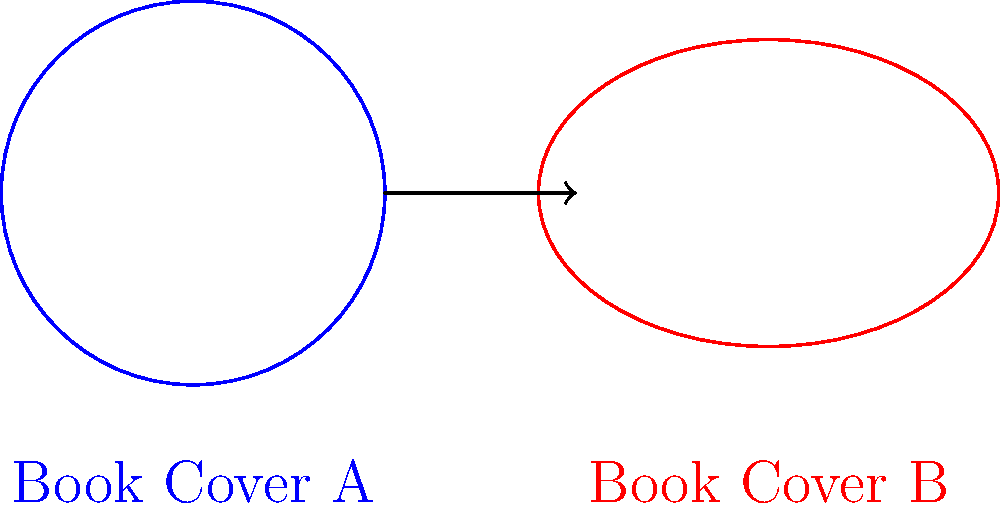Consider two book covers represented by the surfaces shown above: Cover A (blue circle) and Cover B (red ellipse). Are these two surfaces homeomorphic? If so, describe a homeomorphism between them. To determine if the two surfaces are homeomorphic, we need to consider the following steps:

1. Definition of homeomorphism: Two topological spaces are homeomorphic if there exists a continuous bijective function with a continuous inverse between them.

2. Properties of the surfaces:
   a. Cover A is a circle, which is topologically equivalent to $S^1$ (the unit circle).
   b. Cover B is an ellipse, which is also topologically equivalent to $S^1$.

3. Homeomorphism between circle and ellipse:
   a. We can define a continuous bijective function $f: S^1 \to E$ (where $E$ is the ellipse) as follows:
      $f(\cos\theta, \sin\theta) = (a\cos\theta, b\sin\theta)$
      where $a$ and $b$ are the semi-major and semi-minor axes of the ellipse.
   b. The inverse function $f^{-1}: E \to S^1$ is also continuous:
      $f^{-1}(x,y) = (\frac{x}{a}, \frac{y}{b})$

4. Conclusion: Since we can construct a continuous bijective function with a continuous inverse between the circle and the ellipse, they are homeomorphic.

Therefore, the two book covers are indeed homeomorphic, as they are both topologically equivalent to $S^1$.
Answer: Yes, homeomorphic. $f(\cos\theta, \sin\theta) = (a\cos\theta, b\sin\theta)$ 